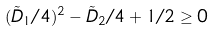Convert formula to latex. <formula><loc_0><loc_0><loc_500><loc_500>( \tilde { D } _ { 1 } / 4 ) ^ { 2 } - \tilde { D } _ { 2 } / 4 + 1 / 2 \geq 0</formula> 